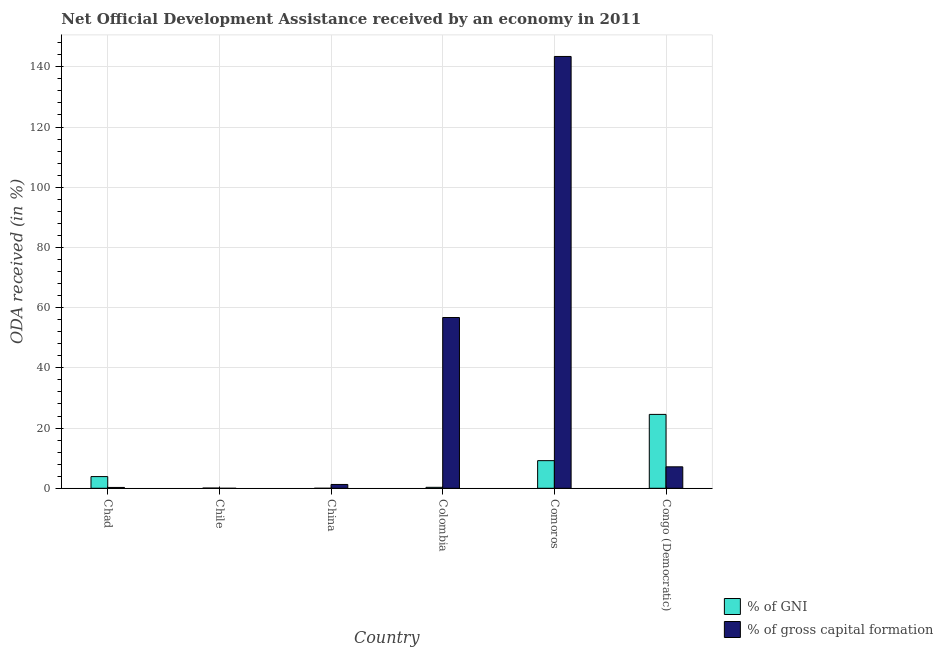How many bars are there on the 4th tick from the left?
Make the answer very short. 2. What is the label of the 5th group of bars from the left?
Ensure brevity in your answer.  Comoros. What is the oda received as percentage of gross capital formation in Congo (Democratic)?
Your response must be concise. 7.13. Across all countries, what is the maximum oda received as percentage of gni?
Offer a terse response. 24.54. In which country was the oda received as percentage of gross capital formation maximum?
Keep it short and to the point. Comoros. What is the total oda received as percentage of gni in the graph?
Provide a short and direct response. 37.99. What is the difference between the oda received as percentage of gni in Chile and that in Comoros?
Provide a succinct answer. -9.11. What is the difference between the oda received as percentage of gross capital formation in China and the oda received as percentage of gni in Colombia?
Give a very brief answer. 0.95. What is the average oda received as percentage of gni per country?
Provide a succinct answer. 6.33. What is the difference between the oda received as percentage of gross capital formation and oda received as percentage of gni in Comoros?
Give a very brief answer. 134.25. What is the ratio of the oda received as percentage of gni in Chile to that in Congo (Democratic)?
Ensure brevity in your answer.  0. Is the oda received as percentage of gni in Chad less than that in Comoros?
Your answer should be compact. Yes. What is the difference between the highest and the second highest oda received as percentage of gni?
Make the answer very short. 15.36. What is the difference between the highest and the lowest oda received as percentage of gross capital formation?
Provide a succinct answer. 143.43. In how many countries, is the oda received as percentage of gross capital formation greater than the average oda received as percentage of gross capital formation taken over all countries?
Provide a short and direct response. 2. Is the sum of the oda received as percentage of gross capital formation in Colombia and Comoros greater than the maximum oda received as percentage of gni across all countries?
Offer a terse response. Yes. How many bars are there?
Your response must be concise. 10. Are all the bars in the graph horizontal?
Make the answer very short. No. Does the graph contain any zero values?
Give a very brief answer. Yes. How many legend labels are there?
Offer a terse response. 2. What is the title of the graph?
Give a very brief answer. Net Official Development Assistance received by an economy in 2011. What is the label or title of the Y-axis?
Offer a very short reply. ODA received (in %). What is the ODA received (in %) of % of GNI in Chad?
Your answer should be very brief. 3.89. What is the ODA received (in %) of % of gross capital formation in Chad?
Make the answer very short. 0.28. What is the ODA received (in %) of % of GNI in Chile?
Provide a short and direct response. 0.07. What is the ODA received (in %) of % of gross capital formation in Chile?
Make the answer very short. 0. What is the ODA received (in %) in % of GNI in China?
Offer a terse response. 0. What is the ODA received (in %) in % of gross capital formation in China?
Your answer should be compact. 1.27. What is the ODA received (in %) in % of GNI in Colombia?
Provide a short and direct response. 0.32. What is the ODA received (in %) in % of gross capital formation in Colombia?
Provide a succinct answer. 56.72. What is the ODA received (in %) in % of GNI in Comoros?
Offer a terse response. 9.18. What is the ODA received (in %) in % of gross capital formation in Comoros?
Offer a very short reply. 143.43. What is the ODA received (in %) in % of GNI in Congo (Democratic)?
Make the answer very short. 24.54. What is the ODA received (in %) of % of gross capital formation in Congo (Democratic)?
Provide a short and direct response. 7.13. Across all countries, what is the maximum ODA received (in %) of % of GNI?
Offer a very short reply. 24.54. Across all countries, what is the maximum ODA received (in %) of % of gross capital formation?
Provide a succinct answer. 143.43. What is the total ODA received (in %) of % of GNI in the graph?
Ensure brevity in your answer.  37.99. What is the total ODA received (in %) of % of gross capital formation in the graph?
Give a very brief answer. 208.83. What is the difference between the ODA received (in %) of % of GNI in Chad and that in Chile?
Your answer should be compact. 3.82. What is the difference between the ODA received (in %) in % of gross capital formation in Chad and that in China?
Make the answer very short. -1. What is the difference between the ODA received (in %) of % of GNI in Chad and that in Colombia?
Give a very brief answer. 3.57. What is the difference between the ODA received (in %) in % of gross capital formation in Chad and that in Colombia?
Ensure brevity in your answer.  -56.45. What is the difference between the ODA received (in %) of % of GNI in Chad and that in Comoros?
Provide a succinct answer. -5.29. What is the difference between the ODA received (in %) in % of gross capital formation in Chad and that in Comoros?
Your answer should be very brief. -143.16. What is the difference between the ODA received (in %) of % of GNI in Chad and that in Congo (Democratic)?
Ensure brevity in your answer.  -20.65. What is the difference between the ODA received (in %) of % of gross capital formation in Chad and that in Congo (Democratic)?
Offer a very short reply. -6.85. What is the difference between the ODA received (in %) of % of GNI in Chile and that in Colombia?
Give a very brief answer. -0.25. What is the difference between the ODA received (in %) of % of GNI in Chile and that in Comoros?
Your answer should be compact. -9.11. What is the difference between the ODA received (in %) of % of GNI in Chile and that in Congo (Democratic)?
Ensure brevity in your answer.  -24.47. What is the difference between the ODA received (in %) in % of gross capital formation in China and that in Colombia?
Provide a succinct answer. -55.45. What is the difference between the ODA received (in %) of % of gross capital formation in China and that in Comoros?
Your response must be concise. -142.16. What is the difference between the ODA received (in %) of % of gross capital formation in China and that in Congo (Democratic)?
Ensure brevity in your answer.  -5.86. What is the difference between the ODA received (in %) in % of GNI in Colombia and that in Comoros?
Provide a succinct answer. -8.86. What is the difference between the ODA received (in %) in % of gross capital formation in Colombia and that in Comoros?
Ensure brevity in your answer.  -86.71. What is the difference between the ODA received (in %) in % of GNI in Colombia and that in Congo (Democratic)?
Offer a very short reply. -24.22. What is the difference between the ODA received (in %) of % of gross capital formation in Colombia and that in Congo (Democratic)?
Your answer should be very brief. 49.6. What is the difference between the ODA received (in %) in % of GNI in Comoros and that in Congo (Democratic)?
Your response must be concise. -15.36. What is the difference between the ODA received (in %) in % of gross capital formation in Comoros and that in Congo (Democratic)?
Keep it short and to the point. 136.31. What is the difference between the ODA received (in %) of % of GNI in Chad and the ODA received (in %) of % of gross capital formation in China?
Keep it short and to the point. 2.62. What is the difference between the ODA received (in %) in % of GNI in Chad and the ODA received (in %) in % of gross capital formation in Colombia?
Give a very brief answer. -52.84. What is the difference between the ODA received (in %) in % of GNI in Chad and the ODA received (in %) in % of gross capital formation in Comoros?
Offer a terse response. -139.55. What is the difference between the ODA received (in %) in % of GNI in Chad and the ODA received (in %) in % of gross capital formation in Congo (Democratic)?
Your answer should be very brief. -3.24. What is the difference between the ODA received (in %) in % of GNI in Chile and the ODA received (in %) in % of gross capital formation in China?
Offer a very short reply. -1.2. What is the difference between the ODA received (in %) in % of GNI in Chile and the ODA received (in %) in % of gross capital formation in Colombia?
Provide a short and direct response. -56.65. What is the difference between the ODA received (in %) in % of GNI in Chile and the ODA received (in %) in % of gross capital formation in Comoros?
Provide a succinct answer. -143.36. What is the difference between the ODA received (in %) of % of GNI in Chile and the ODA received (in %) of % of gross capital formation in Congo (Democratic)?
Your response must be concise. -7.06. What is the difference between the ODA received (in %) in % of GNI in Colombia and the ODA received (in %) in % of gross capital formation in Comoros?
Make the answer very short. -143.11. What is the difference between the ODA received (in %) in % of GNI in Colombia and the ODA received (in %) in % of gross capital formation in Congo (Democratic)?
Offer a terse response. -6.81. What is the difference between the ODA received (in %) of % of GNI in Comoros and the ODA received (in %) of % of gross capital formation in Congo (Democratic)?
Provide a short and direct response. 2.05. What is the average ODA received (in %) in % of GNI per country?
Ensure brevity in your answer.  6.33. What is the average ODA received (in %) of % of gross capital formation per country?
Make the answer very short. 34.8. What is the difference between the ODA received (in %) in % of GNI and ODA received (in %) in % of gross capital formation in Chad?
Your answer should be compact. 3.61. What is the difference between the ODA received (in %) of % of GNI and ODA received (in %) of % of gross capital formation in Colombia?
Provide a succinct answer. -56.4. What is the difference between the ODA received (in %) in % of GNI and ODA received (in %) in % of gross capital formation in Comoros?
Offer a terse response. -134.25. What is the difference between the ODA received (in %) of % of GNI and ODA received (in %) of % of gross capital formation in Congo (Democratic)?
Ensure brevity in your answer.  17.41. What is the ratio of the ODA received (in %) in % of GNI in Chad to that in Chile?
Offer a very short reply. 56.16. What is the ratio of the ODA received (in %) of % of gross capital formation in Chad to that in China?
Provide a short and direct response. 0.22. What is the ratio of the ODA received (in %) in % of GNI in Chad to that in Colombia?
Provide a short and direct response. 12.22. What is the ratio of the ODA received (in %) of % of gross capital formation in Chad to that in Colombia?
Make the answer very short. 0. What is the ratio of the ODA received (in %) of % of GNI in Chad to that in Comoros?
Provide a short and direct response. 0.42. What is the ratio of the ODA received (in %) of % of gross capital formation in Chad to that in Comoros?
Provide a short and direct response. 0. What is the ratio of the ODA received (in %) of % of GNI in Chad to that in Congo (Democratic)?
Offer a terse response. 0.16. What is the ratio of the ODA received (in %) of % of gross capital formation in Chad to that in Congo (Democratic)?
Give a very brief answer. 0.04. What is the ratio of the ODA received (in %) of % of GNI in Chile to that in Colombia?
Offer a very short reply. 0.22. What is the ratio of the ODA received (in %) of % of GNI in Chile to that in Comoros?
Ensure brevity in your answer.  0.01. What is the ratio of the ODA received (in %) in % of GNI in Chile to that in Congo (Democratic)?
Give a very brief answer. 0. What is the ratio of the ODA received (in %) of % of gross capital formation in China to that in Colombia?
Your answer should be very brief. 0.02. What is the ratio of the ODA received (in %) of % of gross capital formation in China to that in Comoros?
Offer a terse response. 0.01. What is the ratio of the ODA received (in %) of % of gross capital formation in China to that in Congo (Democratic)?
Ensure brevity in your answer.  0.18. What is the ratio of the ODA received (in %) of % of GNI in Colombia to that in Comoros?
Provide a succinct answer. 0.03. What is the ratio of the ODA received (in %) of % of gross capital formation in Colombia to that in Comoros?
Provide a short and direct response. 0.4. What is the ratio of the ODA received (in %) in % of GNI in Colombia to that in Congo (Democratic)?
Give a very brief answer. 0.01. What is the ratio of the ODA received (in %) in % of gross capital formation in Colombia to that in Congo (Democratic)?
Offer a terse response. 7.96. What is the ratio of the ODA received (in %) of % of GNI in Comoros to that in Congo (Democratic)?
Your response must be concise. 0.37. What is the ratio of the ODA received (in %) of % of gross capital formation in Comoros to that in Congo (Democratic)?
Make the answer very short. 20.13. What is the difference between the highest and the second highest ODA received (in %) of % of GNI?
Provide a short and direct response. 15.36. What is the difference between the highest and the second highest ODA received (in %) of % of gross capital formation?
Your answer should be compact. 86.71. What is the difference between the highest and the lowest ODA received (in %) in % of GNI?
Offer a very short reply. 24.54. What is the difference between the highest and the lowest ODA received (in %) of % of gross capital formation?
Make the answer very short. 143.43. 